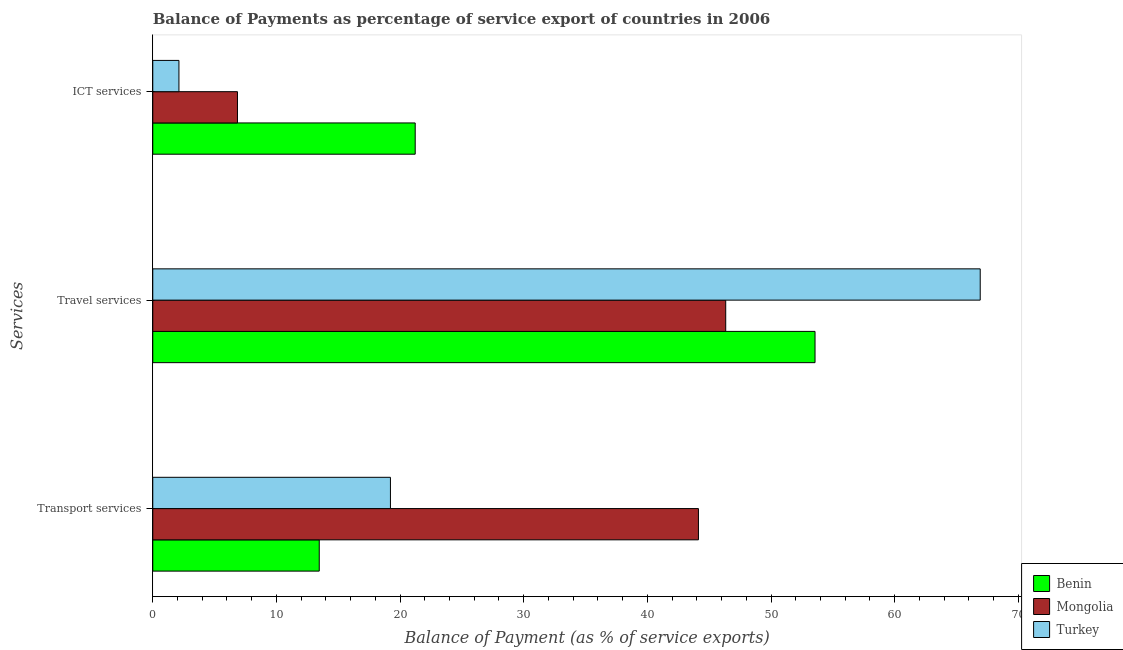How many different coloured bars are there?
Offer a terse response. 3. How many groups of bars are there?
Ensure brevity in your answer.  3. Are the number of bars on each tick of the Y-axis equal?
Keep it short and to the point. Yes. How many bars are there on the 1st tick from the bottom?
Your answer should be very brief. 3. What is the label of the 3rd group of bars from the top?
Offer a terse response. Transport services. What is the balance of payment of travel services in Turkey?
Offer a terse response. 66.92. Across all countries, what is the maximum balance of payment of travel services?
Your answer should be very brief. 66.92. Across all countries, what is the minimum balance of payment of travel services?
Provide a short and direct response. 46.34. In which country was the balance of payment of ict services maximum?
Your answer should be compact. Benin. In which country was the balance of payment of ict services minimum?
Your response must be concise. Turkey. What is the total balance of payment of travel services in the graph?
Your answer should be compact. 166.81. What is the difference between the balance of payment of travel services in Mongolia and that in Benin?
Ensure brevity in your answer.  -7.22. What is the difference between the balance of payment of ict services in Mongolia and the balance of payment of travel services in Benin?
Offer a very short reply. -46.71. What is the average balance of payment of transport services per country?
Your response must be concise. 25.6. What is the difference between the balance of payment of travel services and balance of payment of transport services in Benin?
Make the answer very short. 40.09. What is the ratio of the balance of payment of travel services in Benin to that in Mongolia?
Your response must be concise. 1.16. Is the balance of payment of travel services in Mongolia less than that in Benin?
Provide a short and direct response. Yes. Is the difference between the balance of payment of travel services in Mongolia and Benin greater than the difference between the balance of payment of transport services in Mongolia and Benin?
Make the answer very short. No. What is the difference between the highest and the second highest balance of payment of transport services?
Your answer should be compact. 24.91. What is the difference between the highest and the lowest balance of payment of transport services?
Your answer should be very brief. 30.67. In how many countries, is the balance of payment of ict services greater than the average balance of payment of ict services taken over all countries?
Offer a very short reply. 1. What does the 2nd bar from the top in ICT services represents?
Your response must be concise. Mongolia. Is it the case that in every country, the sum of the balance of payment of transport services and balance of payment of travel services is greater than the balance of payment of ict services?
Your answer should be compact. Yes. How many bars are there?
Your response must be concise. 9. How many countries are there in the graph?
Keep it short and to the point. 3. What is the difference between two consecutive major ticks on the X-axis?
Your answer should be very brief. 10. Does the graph contain grids?
Keep it short and to the point. No. Where does the legend appear in the graph?
Your answer should be compact. Bottom right. How many legend labels are there?
Provide a succinct answer. 3. How are the legend labels stacked?
Give a very brief answer. Vertical. What is the title of the graph?
Your answer should be very brief. Balance of Payments as percentage of service export of countries in 2006. What is the label or title of the X-axis?
Offer a terse response. Balance of Payment (as % of service exports). What is the label or title of the Y-axis?
Provide a short and direct response. Services. What is the Balance of Payment (as % of service exports) of Benin in Transport services?
Your answer should be very brief. 13.46. What is the Balance of Payment (as % of service exports) of Mongolia in Transport services?
Keep it short and to the point. 44.13. What is the Balance of Payment (as % of service exports) in Turkey in Transport services?
Provide a short and direct response. 19.22. What is the Balance of Payment (as % of service exports) in Benin in Travel services?
Provide a succinct answer. 53.56. What is the Balance of Payment (as % of service exports) in Mongolia in Travel services?
Your response must be concise. 46.34. What is the Balance of Payment (as % of service exports) of Turkey in Travel services?
Your response must be concise. 66.92. What is the Balance of Payment (as % of service exports) of Benin in ICT services?
Your response must be concise. 21.22. What is the Balance of Payment (as % of service exports) in Mongolia in ICT services?
Provide a short and direct response. 6.85. What is the Balance of Payment (as % of service exports) of Turkey in ICT services?
Ensure brevity in your answer.  2.12. Across all Services, what is the maximum Balance of Payment (as % of service exports) in Benin?
Ensure brevity in your answer.  53.56. Across all Services, what is the maximum Balance of Payment (as % of service exports) of Mongolia?
Offer a very short reply. 46.34. Across all Services, what is the maximum Balance of Payment (as % of service exports) of Turkey?
Keep it short and to the point. 66.92. Across all Services, what is the minimum Balance of Payment (as % of service exports) of Benin?
Offer a very short reply. 13.46. Across all Services, what is the minimum Balance of Payment (as % of service exports) in Mongolia?
Your answer should be compact. 6.85. Across all Services, what is the minimum Balance of Payment (as % of service exports) in Turkey?
Offer a very short reply. 2.12. What is the total Balance of Payment (as % of service exports) of Benin in the graph?
Keep it short and to the point. 88.25. What is the total Balance of Payment (as % of service exports) in Mongolia in the graph?
Keep it short and to the point. 97.32. What is the total Balance of Payment (as % of service exports) in Turkey in the graph?
Provide a succinct answer. 88.25. What is the difference between the Balance of Payment (as % of service exports) of Benin in Transport services and that in Travel services?
Offer a terse response. -40.09. What is the difference between the Balance of Payment (as % of service exports) in Mongolia in Transport services and that in Travel services?
Your response must be concise. -2.21. What is the difference between the Balance of Payment (as % of service exports) of Turkey in Transport services and that in Travel services?
Give a very brief answer. -47.7. What is the difference between the Balance of Payment (as % of service exports) of Benin in Transport services and that in ICT services?
Your answer should be compact. -7.76. What is the difference between the Balance of Payment (as % of service exports) of Mongolia in Transport services and that in ICT services?
Provide a succinct answer. 37.28. What is the difference between the Balance of Payment (as % of service exports) of Turkey in Transport services and that in ICT services?
Provide a short and direct response. 17.1. What is the difference between the Balance of Payment (as % of service exports) of Benin in Travel services and that in ICT services?
Offer a very short reply. 32.34. What is the difference between the Balance of Payment (as % of service exports) of Mongolia in Travel services and that in ICT services?
Provide a short and direct response. 39.49. What is the difference between the Balance of Payment (as % of service exports) in Turkey in Travel services and that in ICT services?
Provide a succinct answer. 64.8. What is the difference between the Balance of Payment (as % of service exports) of Benin in Transport services and the Balance of Payment (as % of service exports) of Mongolia in Travel services?
Offer a very short reply. -32.87. What is the difference between the Balance of Payment (as % of service exports) in Benin in Transport services and the Balance of Payment (as % of service exports) in Turkey in Travel services?
Keep it short and to the point. -53.45. What is the difference between the Balance of Payment (as % of service exports) in Mongolia in Transport services and the Balance of Payment (as % of service exports) in Turkey in Travel services?
Your response must be concise. -22.79. What is the difference between the Balance of Payment (as % of service exports) in Benin in Transport services and the Balance of Payment (as % of service exports) in Mongolia in ICT services?
Your answer should be very brief. 6.61. What is the difference between the Balance of Payment (as % of service exports) of Benin in Transport services and the Balance of Payment (as % of service exports) of Turkey in ICT services?
Your response must be concise. 11.35. What is the difference between the Balance of Payment (as % of service exports) of Mongolia in Transport services and the Balance of Payment (as % of service exports) of Turkey in ICT services?
Provide a succinct answer. 42.01. What is the difference between the Balance of Payment (as % of service exports) of Benin in Travel services and the Balance of Payment (as % of service exports) of Mongolia in ICT services?
Make the answer very short. 46.71. What is the difference between the Balance of Payment (as % of service exports) of Benin in Travel services and the Balance of Payment (as % of service exports) of Turkey in ICT services?
Provide a short and direct response. 51.44. What is the difference between the Balance of Payment (as % of service exports) of Mongolia in Travel services and the Balance of Payment (as % of service exports) of Turkey in ICT services?
Provide a succinct answer. 44.22. What is the average Balance of Payment (as % of service exports) in Benin per Services?
Make the answer very short. 29.42. What is the average Balance of Payment (as % of service exports) in Mongolia per Services?
Your answer should be very brief. 32.44. What is the average Balance of Payment (as % of service exports) in Turkey per Services?
Offer a terse response. 29.42. What is the difference between the Balance of Payment (as % of service exports) in Benin and Balance of Payment (as % of service exports) in Mongolia in Transport services?
Your response must be concise. -30.67. What is the difference between the Balance of Payment (as % of service exports) of Benin and Balance of Payment (as % of service exports) of Turkey in Transport services?
Your answer should be compact. -5.76. What is the difference between the Balance of Payment (as % of service exports) of Mongolia and Balance of Payment (as % of service exports) of Turkey in Transport services?
Give a very brief answer. 24.91. What is the difference between the Balance of Payment (as % of service exports) in Benin and Balance of Payment (as % of service exports) in Mongolia in Travel services?
Your response must be concise. 7.22. What is the difference between the Balance of Payment (as % of service exports) in Benin and Balance of Payment (as % of service exports) in Turkey in Travel services?
Your answer should be very brief. -13.36. What is the difference between the Balance of Payment (as % of service exports) in Mongolia and Balance of Payment (as % of service exports) in Turkey in Travel services?
Provide a short and direct response. -20.58. What is the difference between the Balance of Payment (as % of service exports) in Benin and Balance of Payment (as % of service exports) in Mongolia in ICT services?
Offer a very short reply. 14.37. What is the difference between the Balance of Payment (as % of service exports) of Benin and Balance of Payment (as % of service exports) of Turkey in ICT services?
Provide a short and direct response. 19.11. What is the difference between the Balance of Payment (as % of service exports) of Mongolia and Balance of Payment (as % of service exports) of Turkey in ICT services?
Keep it short and to the point. 4.73. What is the ratio of the Balance of Payment (as % of service exports) of Benin in Transport services to that in Travel services?
Your response must be concise. 0.25. What is the ratio of the Balance of Payment (as % of service exports) of Mongolia in Transport services to that in Travel services?
Make the answer very short. 0.95. What is the ratio of the Balance of Payment (as % of service exports) of Turkey in Transport services to that in Travel services?
Your response must be concise. 0.29. What is the ratio of the Balance of Payment (as % of service exports) of Benin in Transport services to that in ICT services?
Offer a very short reply. 0.63. What is the ratio of the Balance of Payment (as % of service exports) in Mongolia in Transport services to that in ICT services?
Your answer should be compact. 6.44. What is the ratio of the Balance of Payment (as % of service exports) in Turkey in Transport services to that in ICT services?
Provide a succinct answer. 9.08. What is the ratio of the Balance of Payment (as % of service exports) in Benin in Travel services to that in ICT services?
Your response must be concise. 2.52. What is the ratio of the Balance of Payment (as % of service exports) in Mongolia in Travel services to that in ICT services?
Give a very brief answer. 6.77. What is the ratio of the Balance of Payment (as % of service exports) in Turkey in Travel services to that in ICT services?
Your answer should be compact. 31.62. What is the difference between the highest and the second highest Balance of Payment (as % of service exports) in Benin?
Make the answer very short. 32.34. What is the difference between the highest and the second highest Balance of Payment (as % of service exports) of Mongolia?
Your answer should be compact. 2.21. What is the difference between the highest and the second highest Balance of Payment (as % of service exports) in Turkey?
Give a very brief answer. 47.7. What is the difference between the highest and the lowest Balance of Payment (as % of service exports) in Benin?
Provide a succinct answer. 40.09. What is the difference between the highest and the lowest Balance of Payment (as % of service exports) of Mongolia?
Your response must be concise. 39.49. What is the difference between the highest and the lowest Balance of Payment (as % of service exports) of Turkey?
Make the answer very short. 64.8. 